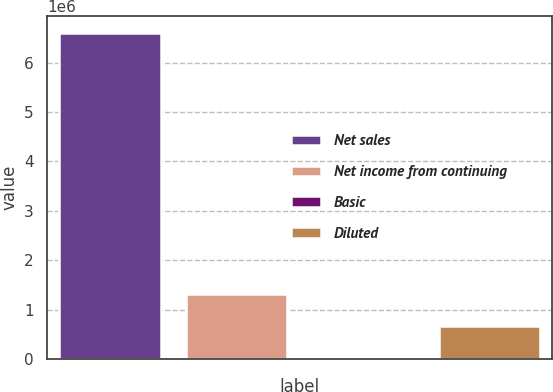Convert chart to OTSL. <chart><loc_0><loc_0><loc_500><loc_500><bar_chart><fcel>Net sales<fcel>Net income from continuing<fcel>Basic<fcel>Diluted<nl><fcel>6.60871e+06<fcel>1.32174e+06<fcel>0.25<fcel>660872<nl></chart> 